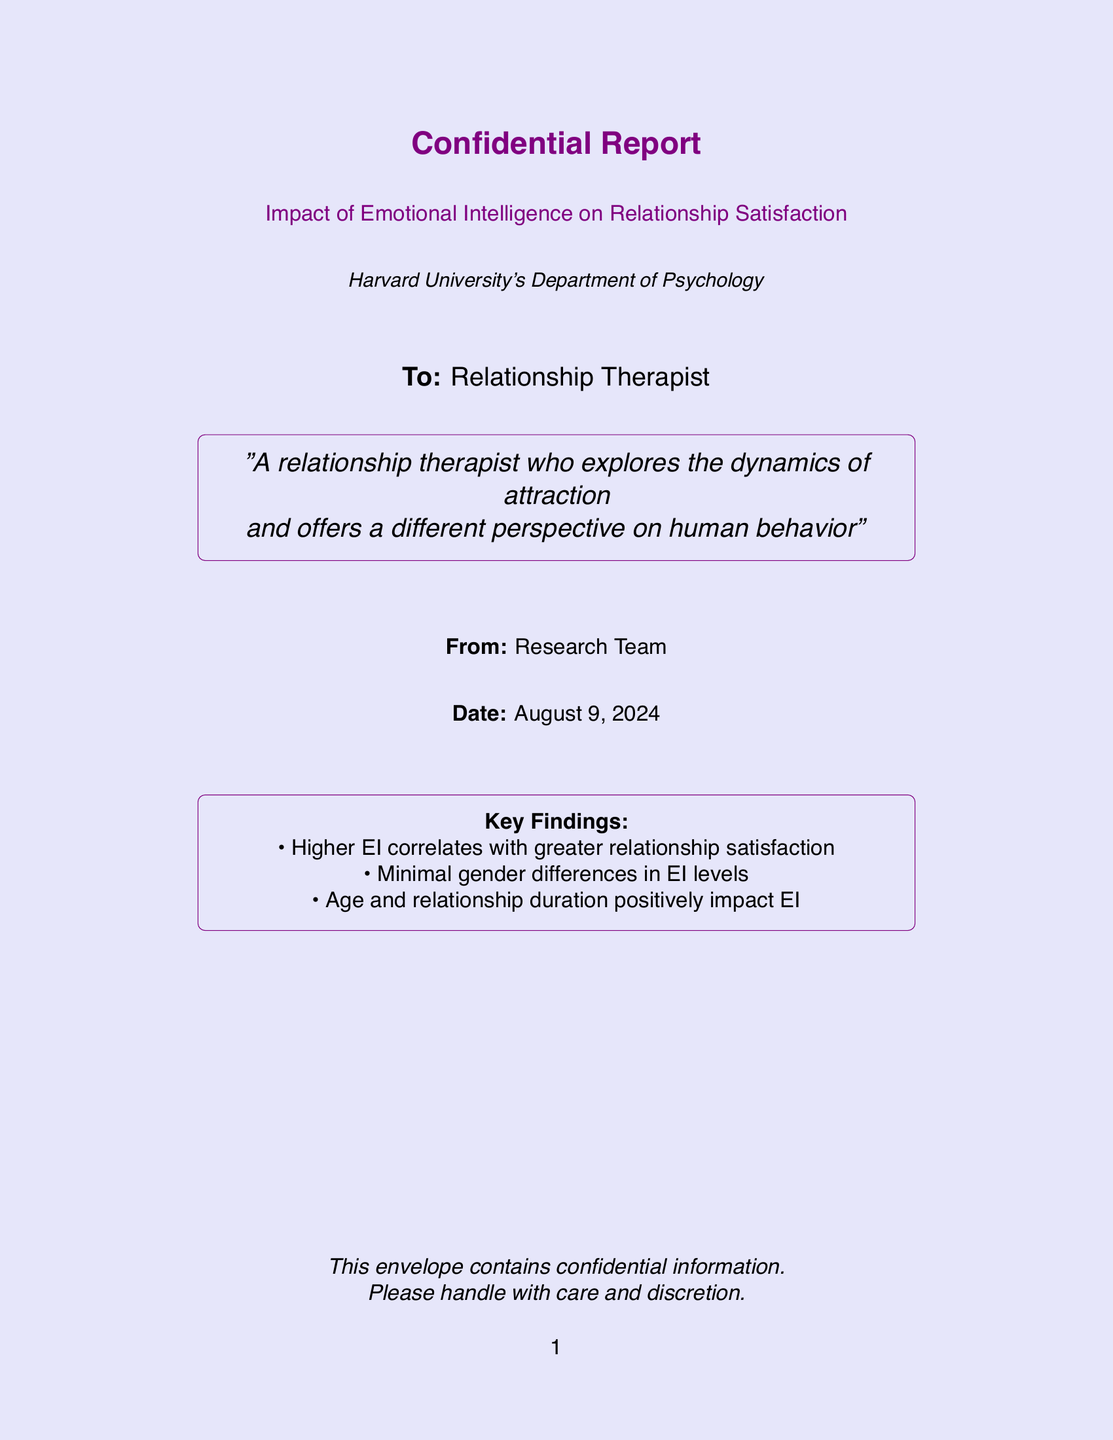What is the title of the report? The title of the report is explicitly mentioned at the beginning of the document.
Answer: Impact of Emotional Intelligence on Relationship Satisfaction Who is the report addressed to? The report specifies the recipient in the addressing section.
Answer: Relationship Therapist What is the date of the report? The date is indicated in the document, which states "Date:".
Answer: today's date What department conducted the research? The department responsible for the research is mentioned in the header of the document.
Answer: Harvard University's Department of Psychology What is the first key finding? The key findings are listed, and the first one is clearly stated.
Answer: Higher EI correlates with greater relationship satisfaction Are there gender differences in EI levels? The findings outline the relationship between gender and EI levels.
Answer: Minimal gender differences in EI levels What factors positively impact EI? The document lists the factors affecting EI, including age and another factor.
Answer: Age and relationship duration What is the color used for the background? The document specifies the background color used.
Answer: light purple What type of document is this? The document's style and structure indicate its formal purpose.
Answer: Confidential Report 